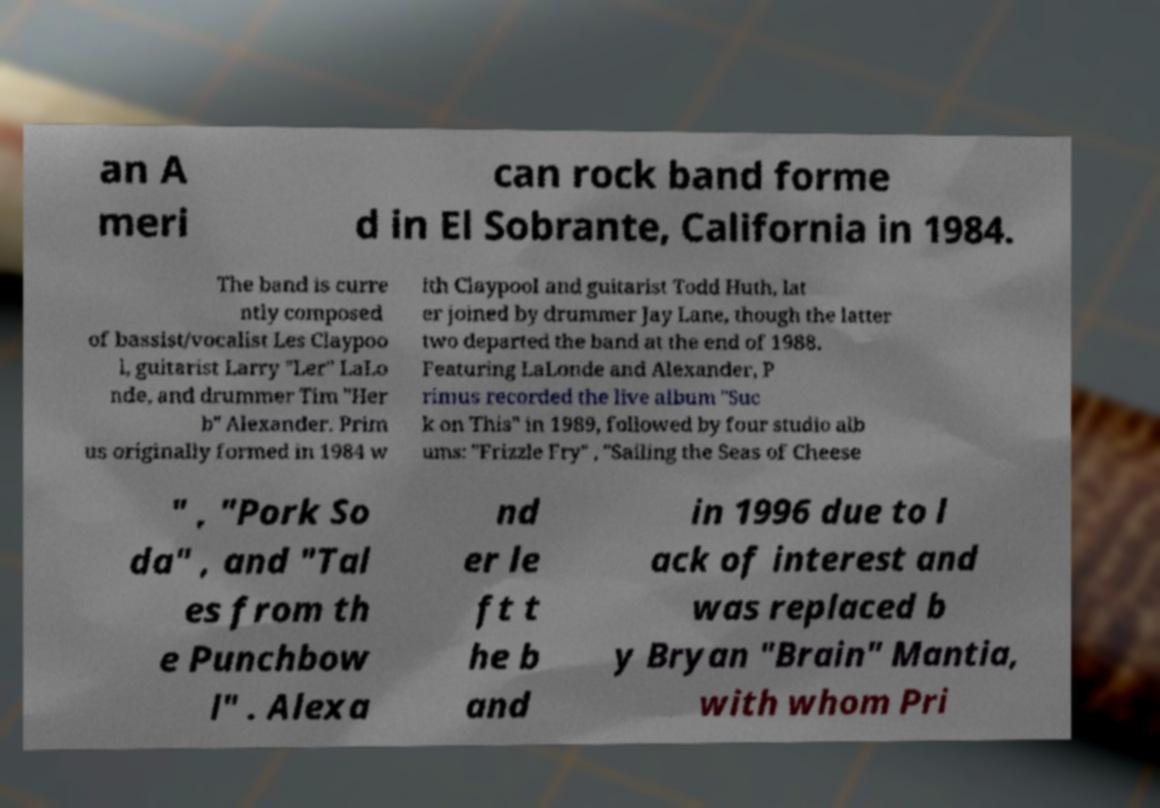For documentation purposes, I need the text within this image transcribed. Could you provide that? an A meri can rock band forme d in El Sobrante, California in 1984. The band is curre ntly composed of bassist/vocalist Les Claypoo l, guitarist Larry "Ler" LaLo nde, and drummer Tim "Her b" Alexander. Prim us originally formed in 1984 w ith Claypool and guitarist Todd Huth, lat er joined by drummer Jay Lane, though the latter two departed the band at the end of 1988. Featuring LaLonde and Alexander, P rimus recorded the live album "Suc k on This" in 1989, followed by four studio alb ums: "Frizzle Fry" , "Sailing the Seas of Cheese " , "Pork So da" , and "Tal es from th e Punchbow l" . Alexa nd er le ft t he b and in 1996 due to l ack of interest and was replaced b y Bryan "Brain" Mantia, with whom Pri 